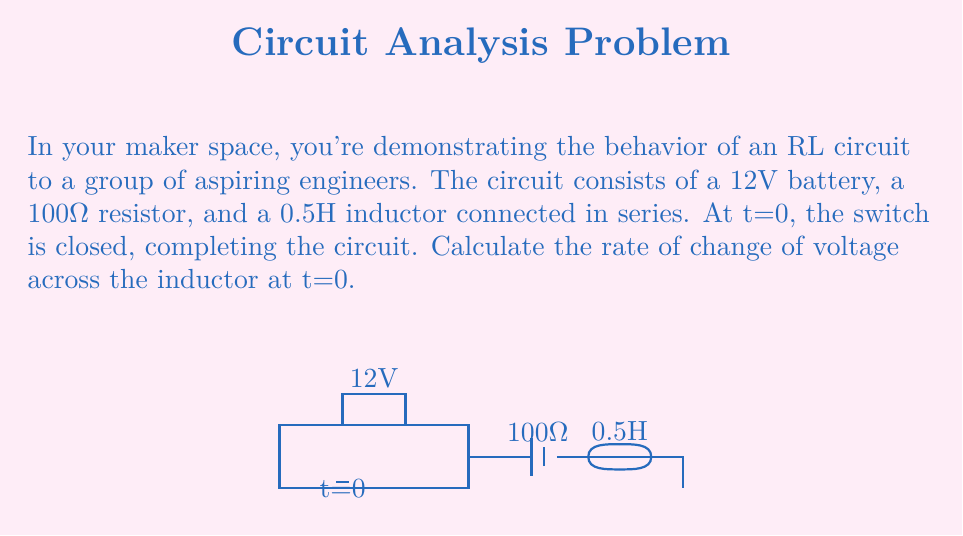What is the answer to this math problem? Let's approach this step-by-step:

1) In an RL circuit, the voltage across the inductor ($V_L$) is related to the current ($i$) by:

   $$V_L = L\frac{di}{dt}$$

   where $L$ is the inductance.

2) At t=0, just when the switch is closed, the current in the circuit is zero and starts to increase. The full battery voltage appears across the inductor at this instant.

3) We can use Kirchhoff's Voltage Law (KVL) to set up our equation:

   $$V_{battery} = V_R + V_L$$

   where $V_R$ is the voltage across the resistor.

4) At t=0, $V_R = 0$ (since $i = 0$), so:

   $$V_L = V_{battery} = 12V$$

5) Substituting this into the inductor equation:

   $$12 = 0.5\frac{di}{dt}$$

6) Solving for $\frac{di}{dt}$:

   $$\frac{di}{dt} = \frac{12}{0.5} = 24 \text{ A/s}$$

7) Now, to find the rate of change of voltage across the inductor, we need to differentiate the inductor equation with respect to time:

   $$\frac{dV_L}{dt} = L\frac{d^2i}{dt^2}$$

8) In an RL circuit, $\frac{d^2i}{dt^2}$ at t=0 is:

   $$\frac{d^2i}{dt^2} = -\frac{R}{L}\frac{di}{dt}$$

9) Substituting our known values:

   $$\frac{d^2i}{dt^2} = -\frac{100}{0.5}(24) = -4800 \text{ A/s}^2$$

10) Finally, we can calculate $\frac{dV_L}{dt}$:

    $$\frac{dV_L}{dt} = 0.5(-4800) = -2400 \text{ V/s}$$
Answer: $-2400 \text{ V/s}$ 